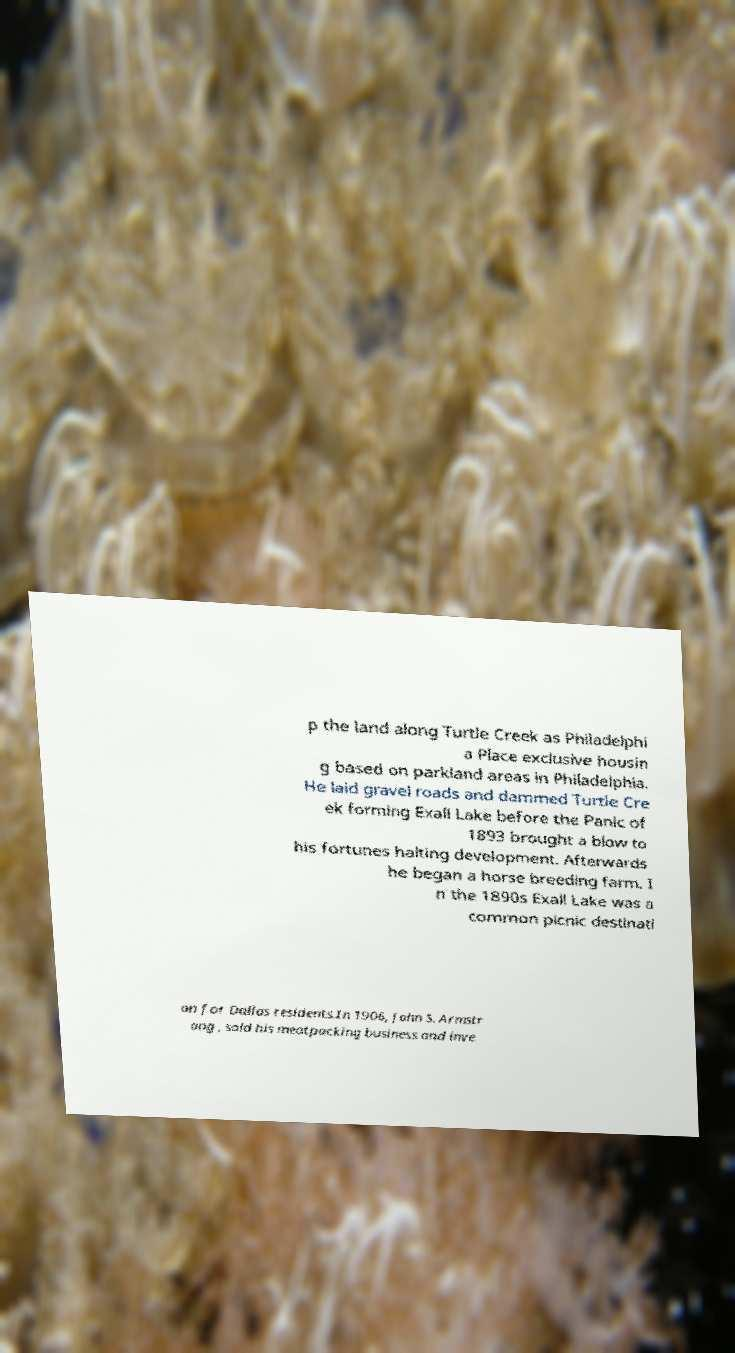Could you assist in decoding the text presented in this image and type it out clearly? p the land along Turtle Creek as Philadelphi a Place exclusive housin g based on parkland areas in Philadelphia. He laid gravel roads and dammed Turtle Cre ek forming Exall Lake before the Panic of 1893 brought a blow to his fortunes halting development. Afterwards he began a horse breeding farm. I n the 1890s Exall Lake was a common picnic destinati on for Dallas residents.In 1906, John S. Armstr ong , sold his meatpacking business and inve 